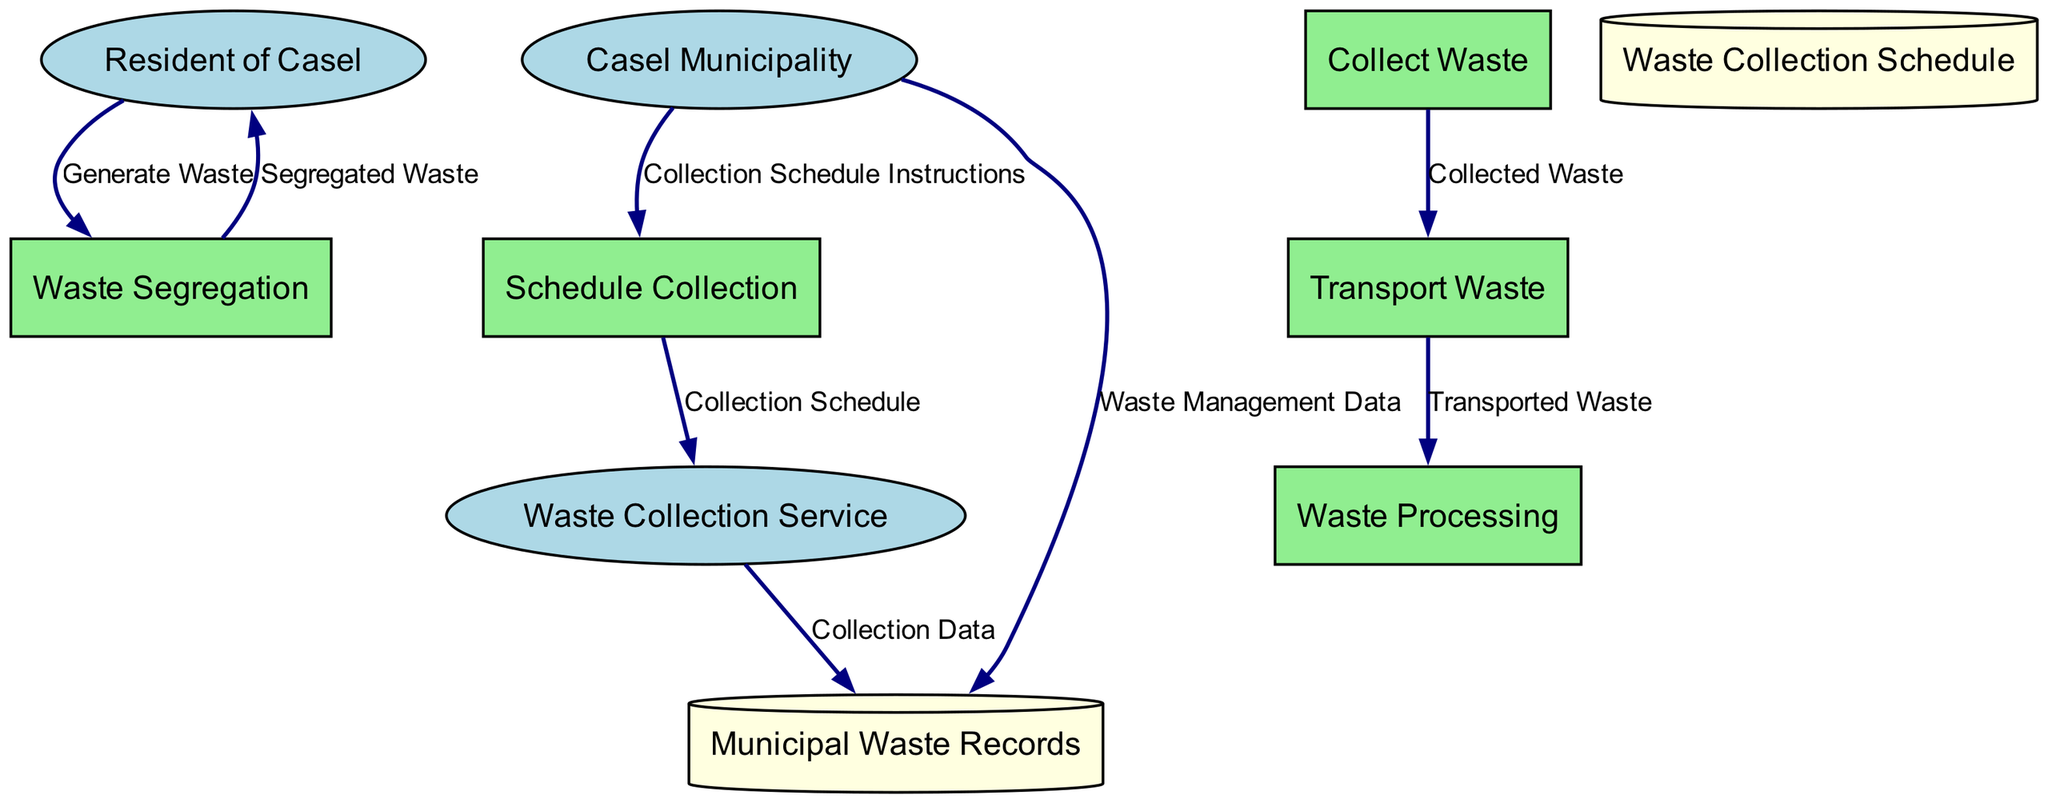What are the external entities involved in the waste disposal process? The external entities identified in the diagram include the "Resident of Casel," "Waste Collection Service," and "Casel Municipality." These entities interact with the processes outlined in the diagram.
Answer: Resident of Casel, Waste Collection Service, Casel Municipality How many processes are there in this waste disposal system? The diagram lists five distinct processes: "Waste Segregation," "Schedule Collection," "Collect Waste," "Transport Waste," and "Waste Processing." Hence, there are a total of five processes.
Answer: 5 What is the output of the "Waste Segregation" process? The "Waste Segregation" process outputs "Segregated Waste," which is ready for collection. This flow indicates that the waste has been sorted into appropriate categories after being generated by the residents.
Answer: Segregated Waste Which process receives the "Collection Schedule Instructions"? The "Schedule Collection" process receives the "Collection Schedule Instructions" from the "Casel Municipality." This flow shows the communication of scheduling details needed to arrange waste collection from the residents.
Answer: Schedule Collection What data flows from the "Waste Collection Service" to the "Municipal Waste Records"? The data that flows from the "Waste Collection Service" to the "Municipal Waste Records" is called "Collection Data." This flow captures the information related to the collected waste for documentation and tracking by the municipality.
Answer: Collection Data Which entity is responsible for instructing the scheduling of waste collection? The "Casel Municipality" is responsible for providing the "Collection Schedule Instructions." This indicates that the municipality plays a key role in organizing when and how often waste is collected from residents.
Answer: Casel Municipality How is the "Transported Waste" produced within the flow? The "Transported Waste" is produced as a result of the "Collect Waste" process sending the "Collected Waste" to the "Transport Waste" process. This flow shows the movement of waste from collection to transport for further processing.
Answer: Transported Waste How many data stores are depicted in this diagram? The diagram features two data stores: "Waste Collection Schedule" and "Municipal Waste Records." These stores are utilized to hold pertinent information about the waste management processes in Casel.
Answer: 2 What happens to the data related to waste management activities? The data related to waste management activities is sent to "Municipal Waste Records" from the "Casel Municipality." This shows that the municipality documents and records actions taken in waste management for accountability and analysis.
Answer: Municipal Waste Records 